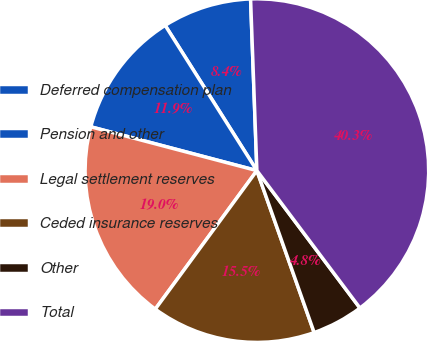<chart> <loc_0><loc_0><loc_500><loc_500><pie_chart><fcel>Deferred compensation plan<fcel>Pension and other<fcel>Legal settlement reserves<fcel>Ceded insurance reserves<fcel>Other<fcel>Total<nl><fcel>8.38%<fcel>11.93%<fcel>19.03%<fcel>15.48%<fcel>4.83%<fcel>40.34%<nl></chart> 